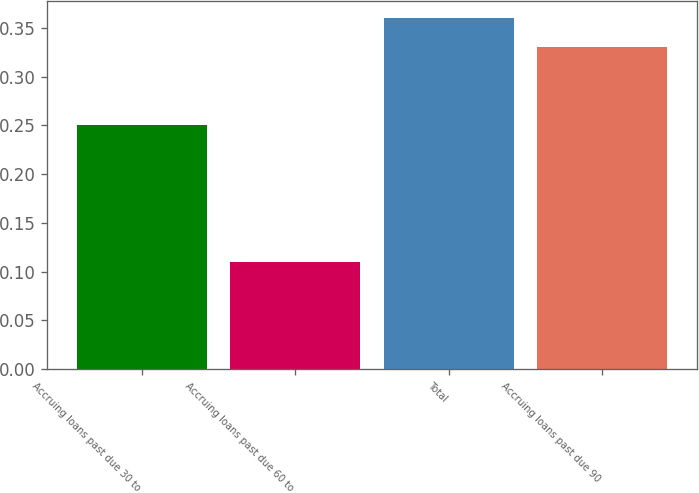<chart> <loc_0><loc_0><loc_500><loc_500><bar_chart><fcel>Accruing loans past due 30 to<fcel>Accruing loans past due 60 to<fcel>Total<fcel>Accruing loans past due 90<nl><fcel>0.25<fcel>0.11<fcel>0.36<fcel>0.33<nl></chart> 